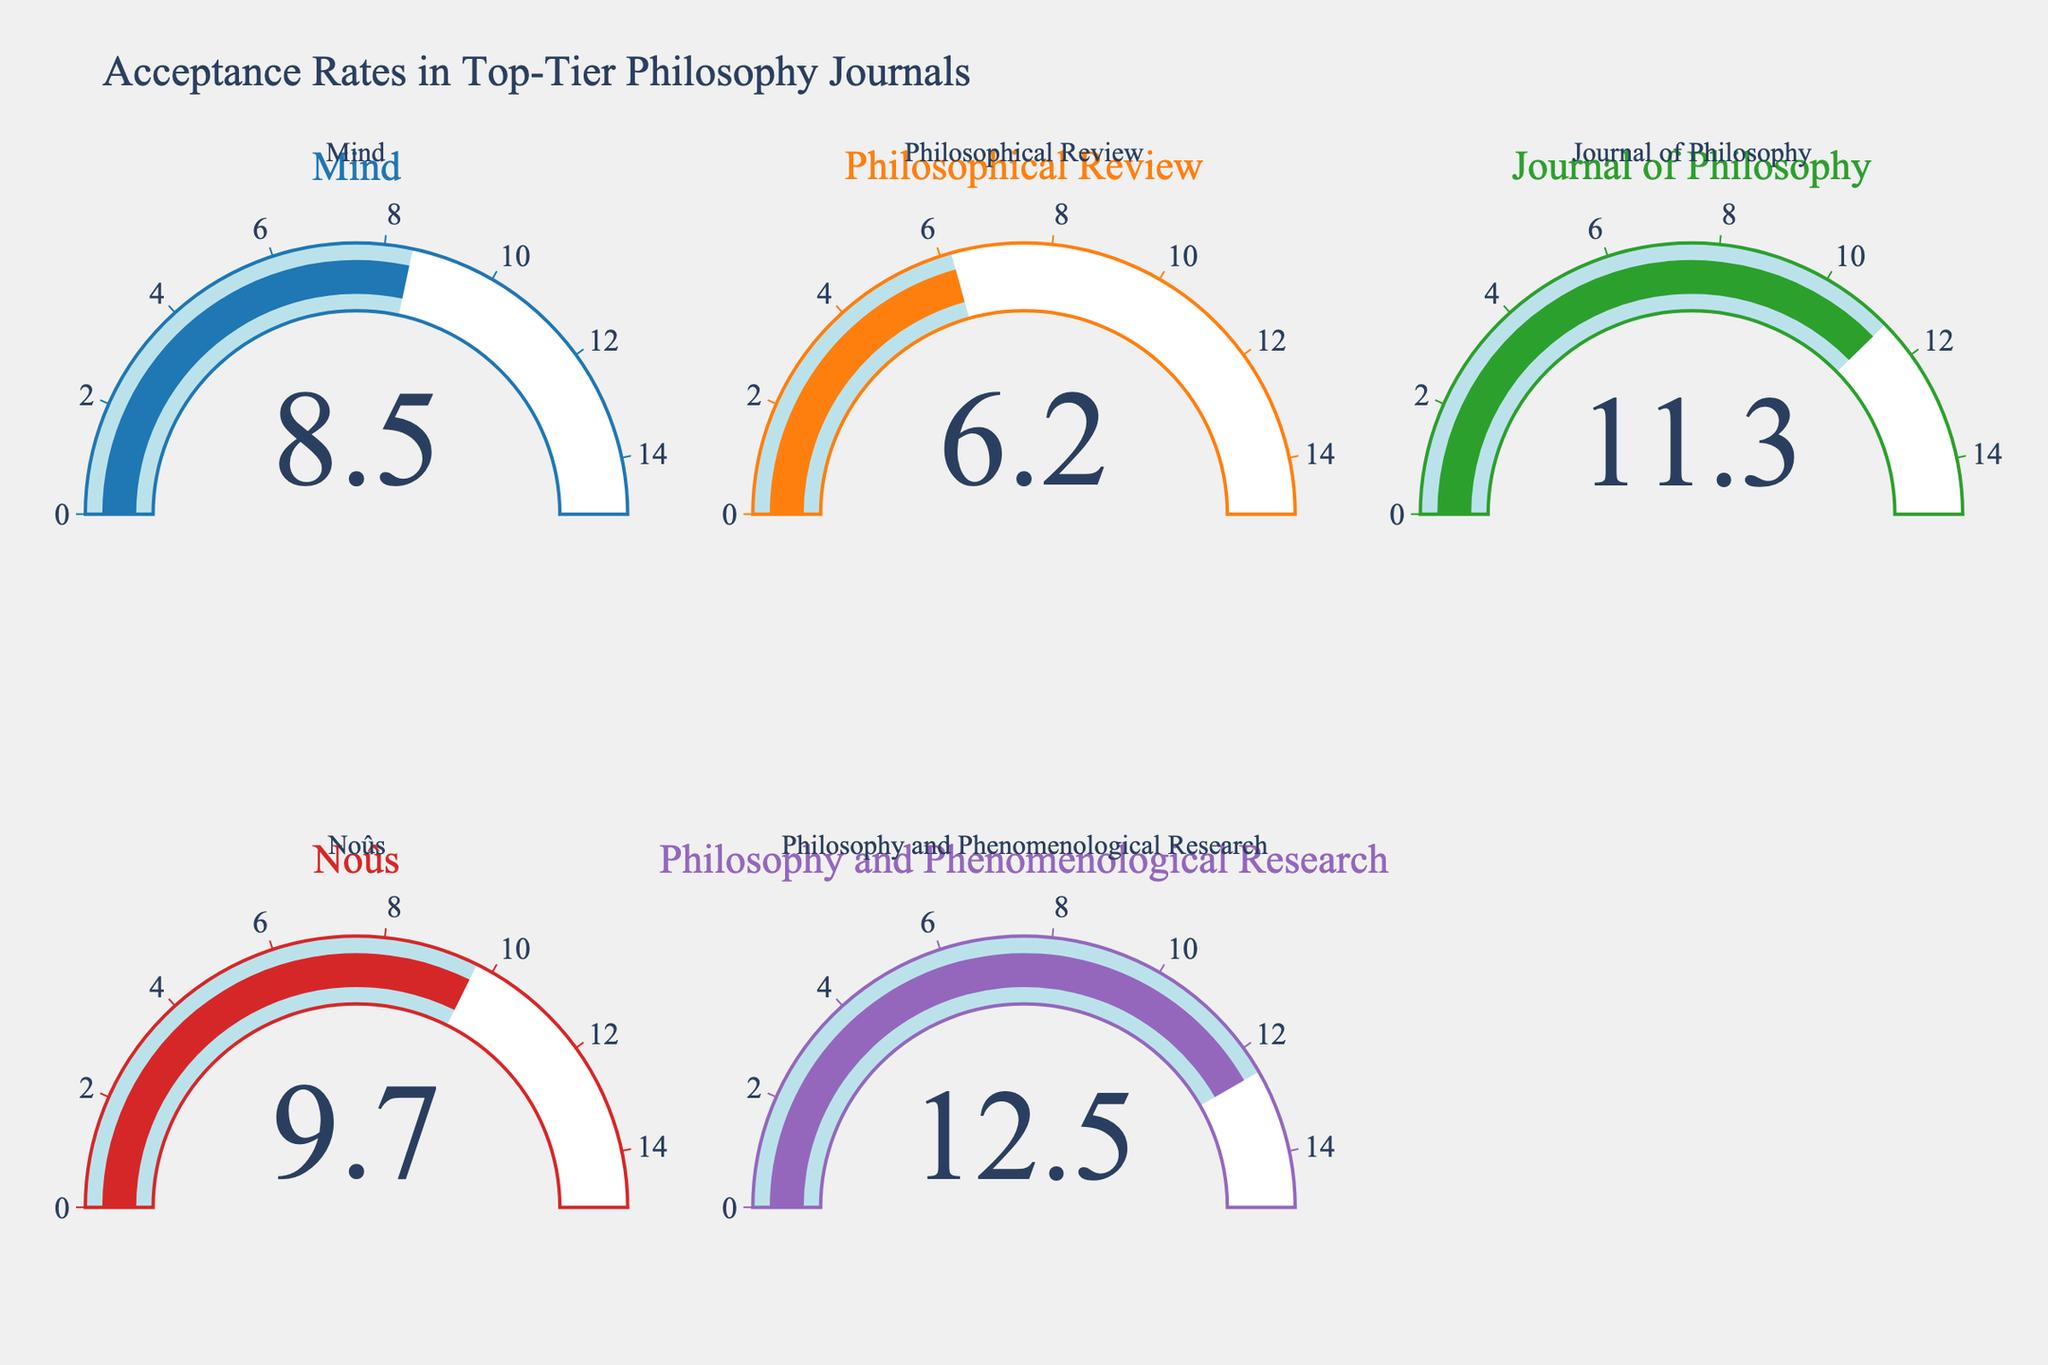What is the acceptance rate for the journal "Mind"? To find the acceptance rate for "Mind," look at the respective gauge chart for "Mind" and read the displayed number.
Answer: 8.5% Which journal has the lowest acceptance rate? Compare the displayed acceptance rates across all journal gauges to identify the lowest number.
Answer: Philosophical Review What is the sum of acceptance rates for "Mind" and "Noûs"? Add the acceptance rates shown in the gauges for "Mind" (8.5) and "Noûs" (9.7): 8.5 + 9.7.
Answer: 18.2 How many journals have an acceptance rate higher than 10%? Identify the journals whose gauge charts show acceptance rates greater than 10% (for "Journal of Philosophy" and "Philosophy and Phenomenological Research").
Answer: 2 What is the average acceptance rate for all the journals displayed? Sum all the acceptance rates (8.5 + 6.2 + 11.3 + 9.7 + 12.5) and divide by the number of journals (5): (8.5 + 6.2 + 11.3 + 9.7 + 12.5) / 5.
Answer: 9.64 Which journal has the highest acceptance rate, and what is that rate? Identify the journal with the largest number displayed in its gauge chart ("Philosophy and Phenomenological Research" at 12.5).
Answer: Philosophy and Phenomenological Research, 12.5% Is the acceptance rate for "Philosophical Review" less than 7%? Check the displayed number in the gauge chart for "Philosophical Review" and see if it is below 7%.
Answer: Yes What is the difference in acceptance rates between "Journal of Philosophy" and "Mind"? Subtract the acceptance rate of "Mind" (8.5) from that of "Journal of Philosophy" (11.3): 11.3 - 8.5.
Answer: 2.8 What's the median acceptance rate of the journals? List the acceptance rates in ascending order (6.2, 8.5, 9.7, 11.3, 12.5) and identify the middle value, which is the median.
Answer: 9.7 